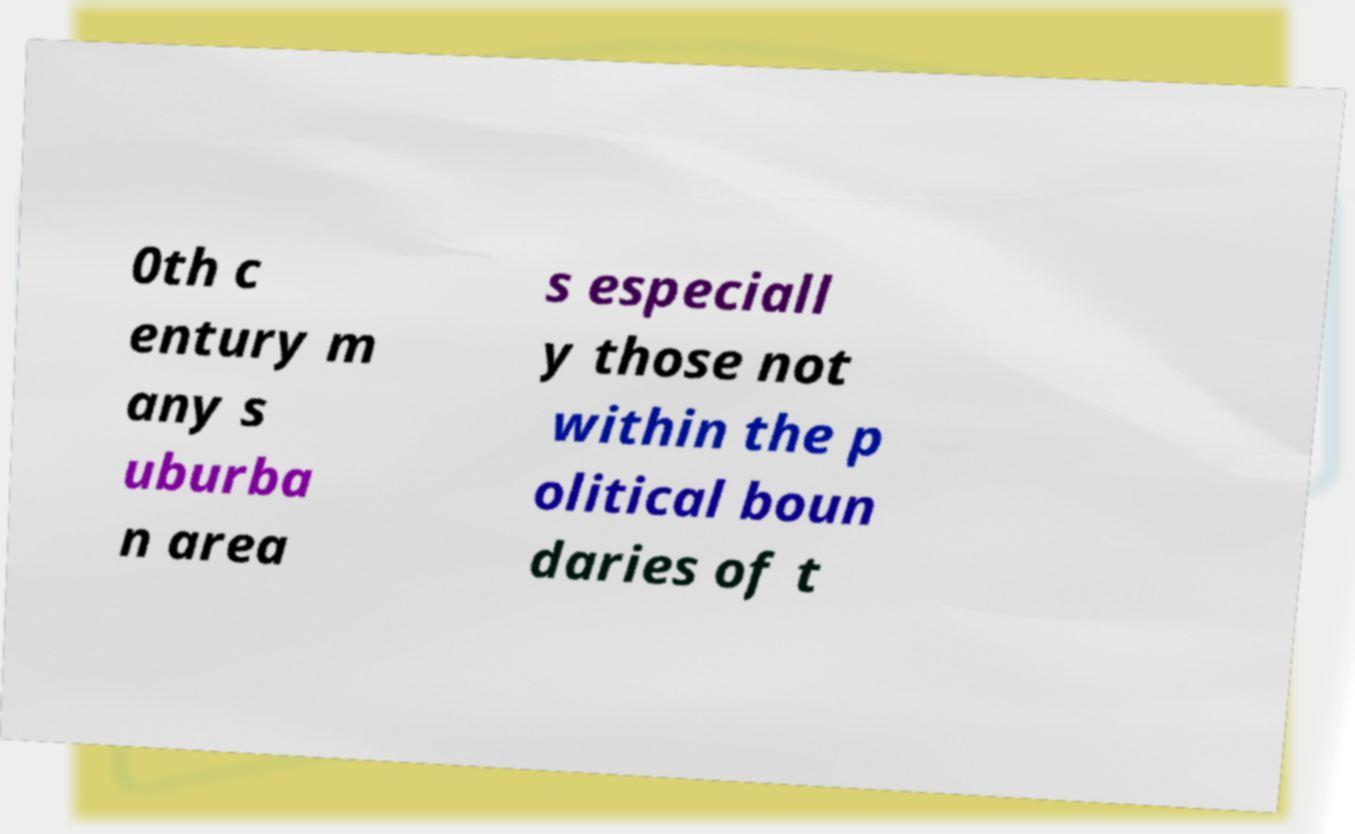Please identify and transcribe the text found in this image. 0th c entury m any s uburba n area s especiall y those not within the p olitical boun daries of t 